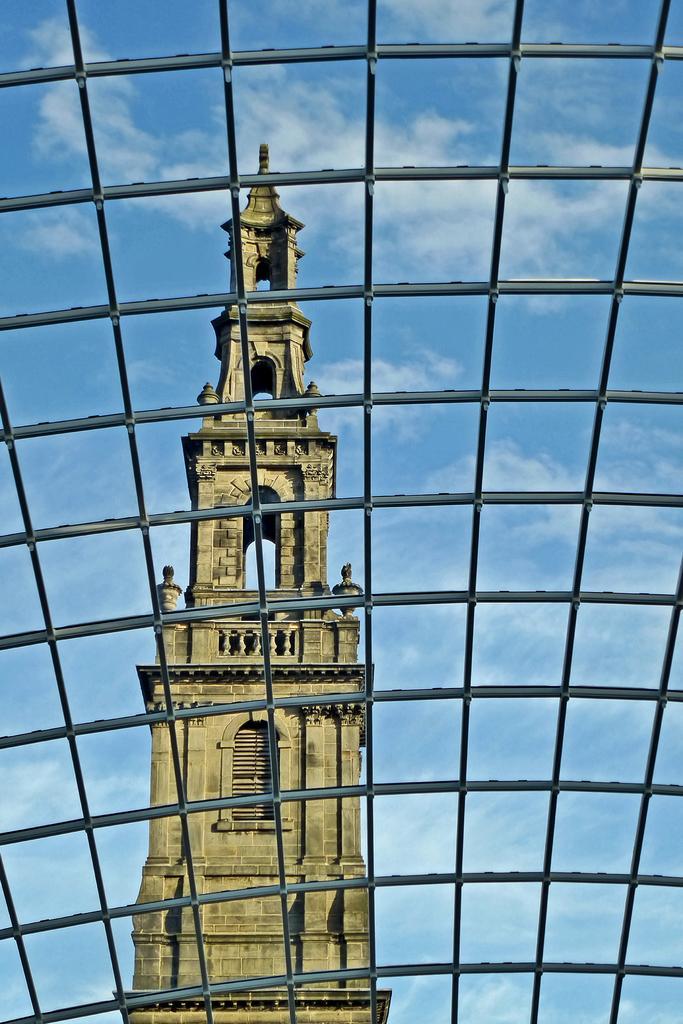In one or two sentences, can you explain what this image depicts? In this image in the foreground there are some grills, and in the background there is one building and sky. 